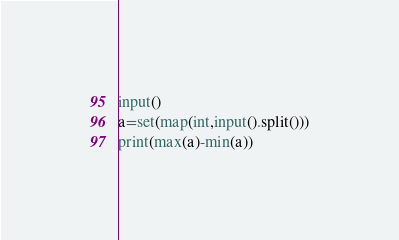<code> <loc_0><loc_0><loc_500><loc_500><_Python_>input()
a=set(map(int,input().split()))
print(max(a)-min(a))</code> 